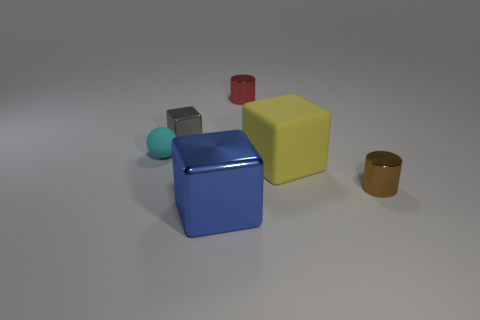Subtract all blue cubes. How many cubes are left? 2 Add 1 large cyan shiny blocks. How many objects exist? 7 Subtract all spheres. How many objects are left? 5 Subtract all green blocks. Subtract all green balls. How many blocks are left? 3 Add 6 small brown things. How many small brown things are left? 7 Add 1 green balls. How many green balls exist? 1 Subtract 1 gray cubes. How many objects are left? 5 Subtract all metal things. Subtract all large yellow objects. How many objects are left? 1 